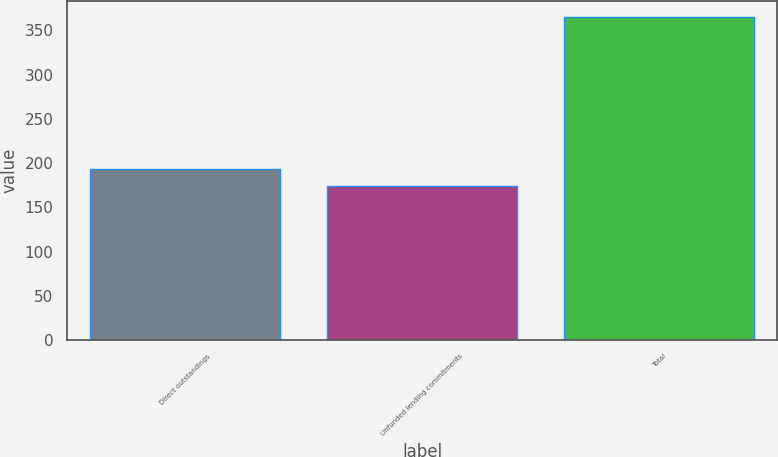<chart> <loc_0><loc_0><loc_500><loc_500><bar_chart><fcel>Direct outstandings<fcel>Unfunded lending commitments<fcel>Total<nl><fcel>193.1<fcel>174<fcel>365<nl></chart> 